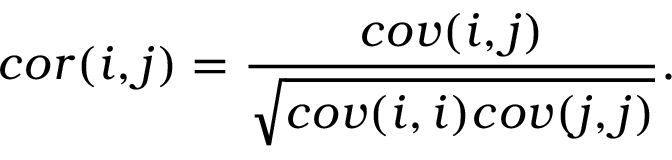<formula> <loc_0><loc_0><loc_500><loc_500>c o r ( i , j ) = \frac { c o v ( i , j ) } { \sqrt { c o v ( i , i ) c o v ( j , j ) } } .</formula> 